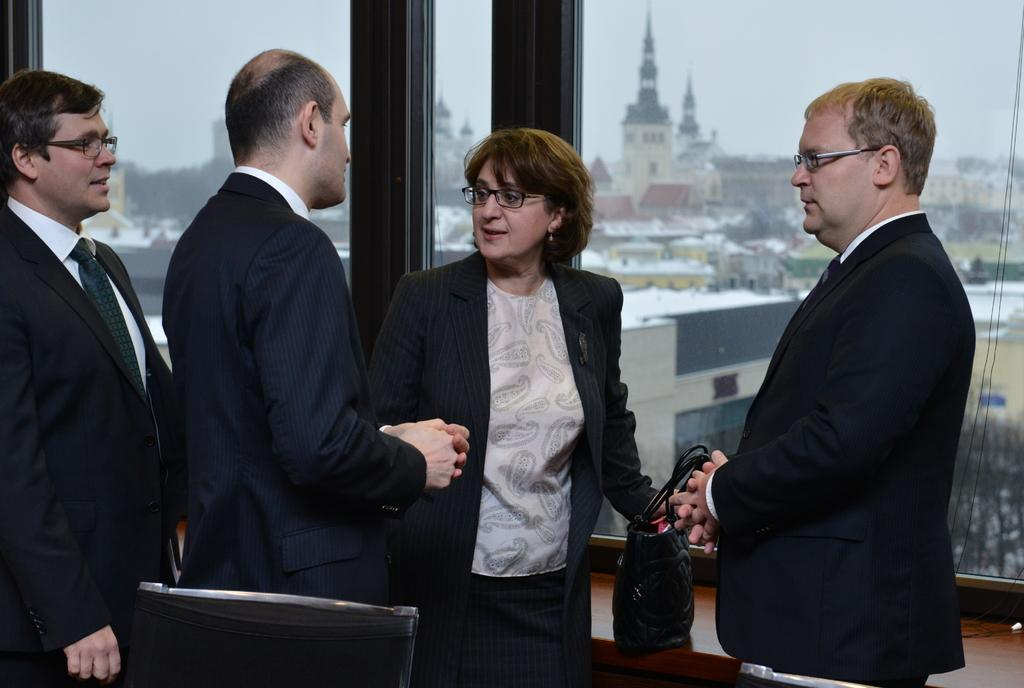How many people are present in the room? There are four people standing in the room. What is on the table in the room? There is a bag on the table. Who is holding the bag? A woman is holding the bag. Can you describe the seating arrangement in the room? There is a chair beside one of the people. What can be seen in the distance behind the people? Buildings are visible in the background. What type of wheel is attached to the bag in the image? There is no wheel attached to the bag in the image. How does the woman in the image express regret? There is no indication of regret in the image; it only shows four people standing in a room with a bag on the table. 